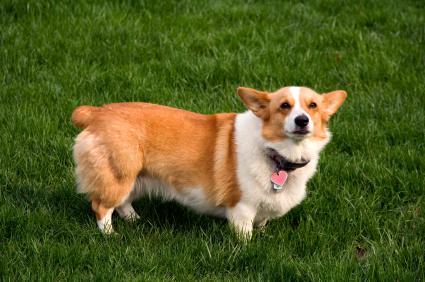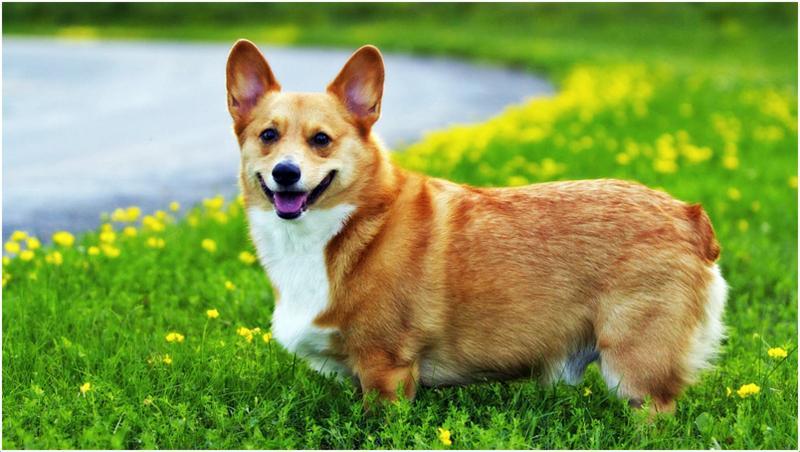The first image is the image on the left, the second image is the image on the right. Evaluate the accuracy of this statement regarding the images: "The dogs in the images are in profile, with one body turned to the right and the other to the left.". Is it true? Answer yes or no. Yes. 